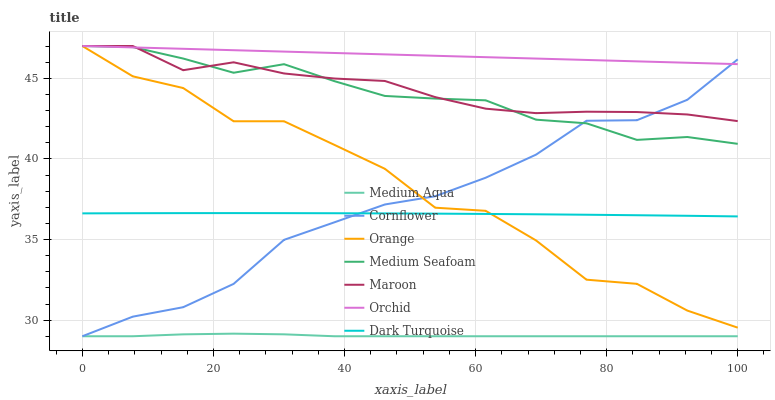Does Medium Aqua have the minimum area under the curve?
Answer yes or no. Yes. Does Orchid have the maximum area under the curve?
Answer yes or no. Yes. Does Dark Turquoise have the minimum area under the curve?
Answer yes or no. No. Does Dark Turquoise have the maximum area under the curve?
Answer yes or no. No. Is Orchid the smoothest?
Answer yes or no. Yes. Is Orange the roughest?
Answer yes or no. Yes. Is Dark Turquoise the smoothest?
Answer yes or no. No. Is Dark Turquoise the roughest?
Answer yes or no. No. Does Cornflower have the lowest value?
Answer yes or no. Yes. Does Dark Turquoise have the lowest value?
Answer yes or no. No. Does Orchid have the highest value?
Answer yes or no. Yes. Does Dark Turquoise have the highest value?
Answer yes or no. No. Is Medium Aqua less than Orange?
Answer yes or no. Yes. Is Orchid greater than Medium Aqua?
Answer yes or no. Yes. Does Medium Seafoam intersect Maroon?
Answer yes or no. Yes. Is Medium Seafoam less than Maroon?
Answer yes or no. No. Is Medium Seafoam greater than Maroon?
Answer yes or no. No. Does Medium Aqua intersect Orange?
Answer yes or no. No. 